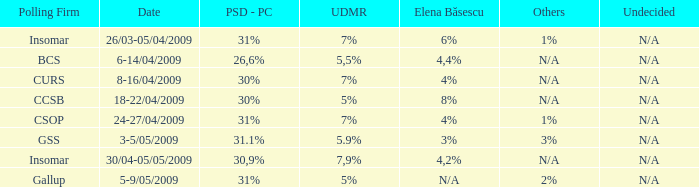When did elena basescu collaborate with the gallup polling firm? N/A. 